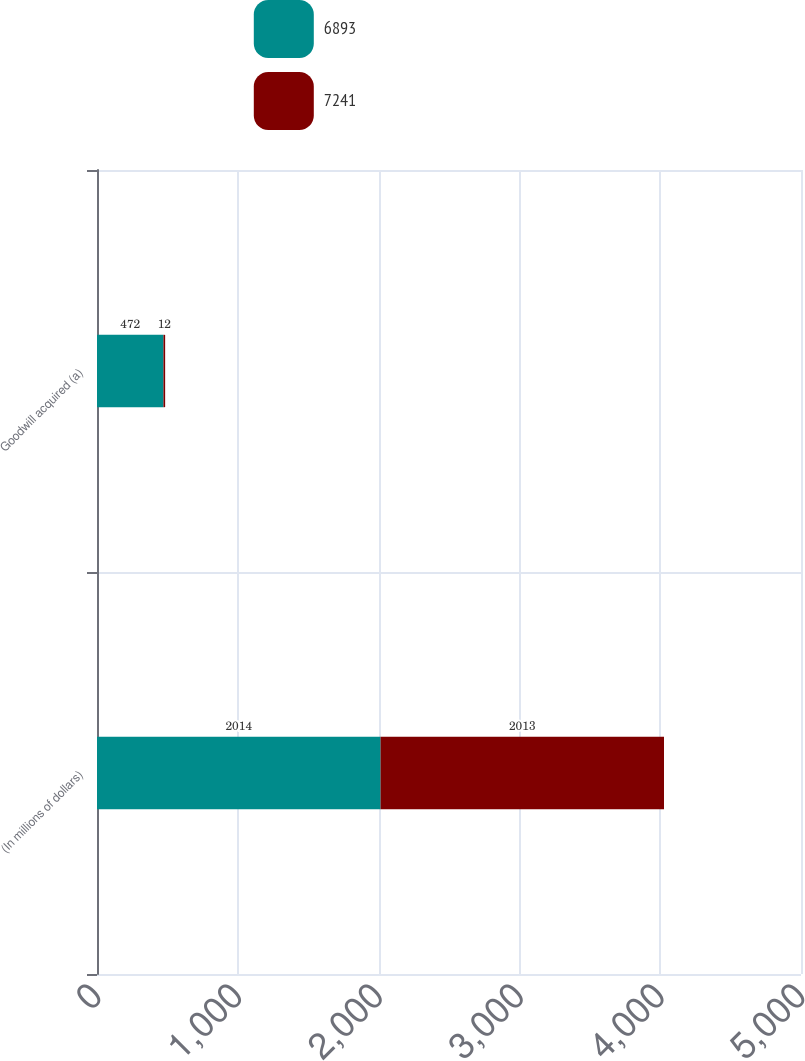<chart> <loc_0><loc_0><loc_500><loc_500><stacked_bar_chart><ecel><fcel>(In millions of dollars)<fcel>Goodwill acquired (a)<nl><fcel>6893<fcel>2014<fcel>472<nl><fcel>7241<fcel>2013<fcel>12<nl></chart> 